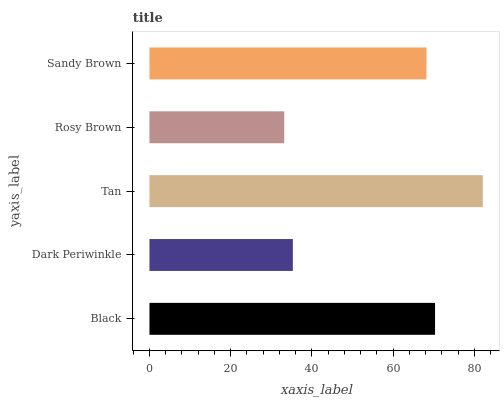Is Rosy Brown the minimum?
Answer yes or no. Yes. Is Tan the maximum?
Answer yes or no. Yes. Is Dark Periwinkle the minimum?
Answer yes or no. No. Is Dark Periwinkle the maximum?
Answer yes or no. No. Is Black greater than Dark Periwinkle?
Answer yes or no. Yes. Is Dark Periwinkle less than Black?
Answer yes or no. Yes. Is Dark Periwinkle greater than Black?
Answer yes or no. No. Is Black less than Dark Periwinkle?
Answer yes or no. No. Is Sandy Brown the high median?
Answer yes or no. Yes. Is Sandy Brown the low median?
Answer yes or no. Yes. Is Rosy Brown the high median?
Answer yes or no. No. Is Rosy Brown the low median?
Answer yes or no. No. 